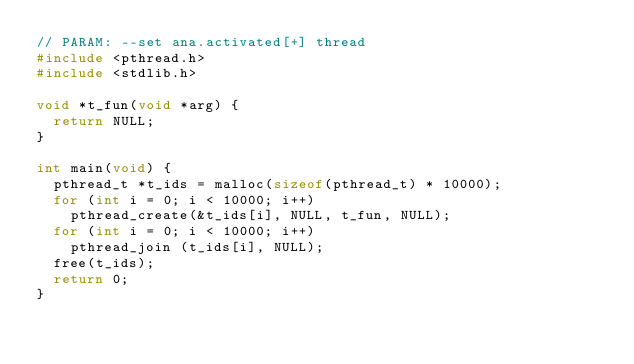Convert code to text. <code><loc_0><loc_0><loc_500><loc_500><_C_>// PARAM: --set ana.activated[+] thread
#include <pthread.h>
#include <stdlib.h>

void *t_fun(void *arg) {
  return NULL;
}

int main(void) {
  pthread_t *t_ids = malloc(sizeof(pthread_t) * 10000);
  for (int i = 0; i < 10000; i++)
    pthread_create(&t_ids[i], NULL, t_fun, NULL);
  for (int i = 0; i < 10000; i++)
    pthread_join (t_ids[i], NULL);
  free(t_ids);
  return 0;
}</code> 